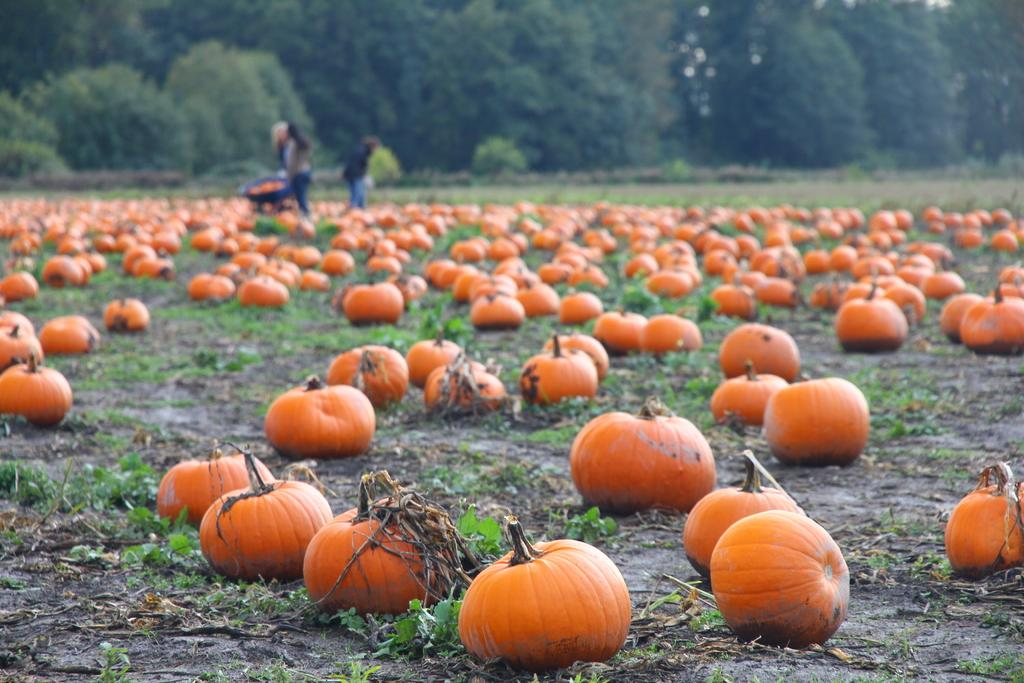What objects are on the ground in the image? There are pumpkins on the ground in the image. What can be seen in the background of the image? There are trees visible in the background of the image. Are there any people present in the image? Yes, there are people standing at the back of the image. How is the image quality at the back? The image is slightly blurry at the back. What type of sweater is the toy wearing in the image? There is no toy or sweater present in the image; it features pumpkins on the ground and people standing at the back. Can you tell me how many chess pieces are visible in the image? There are no chess pieces visible in the image. 